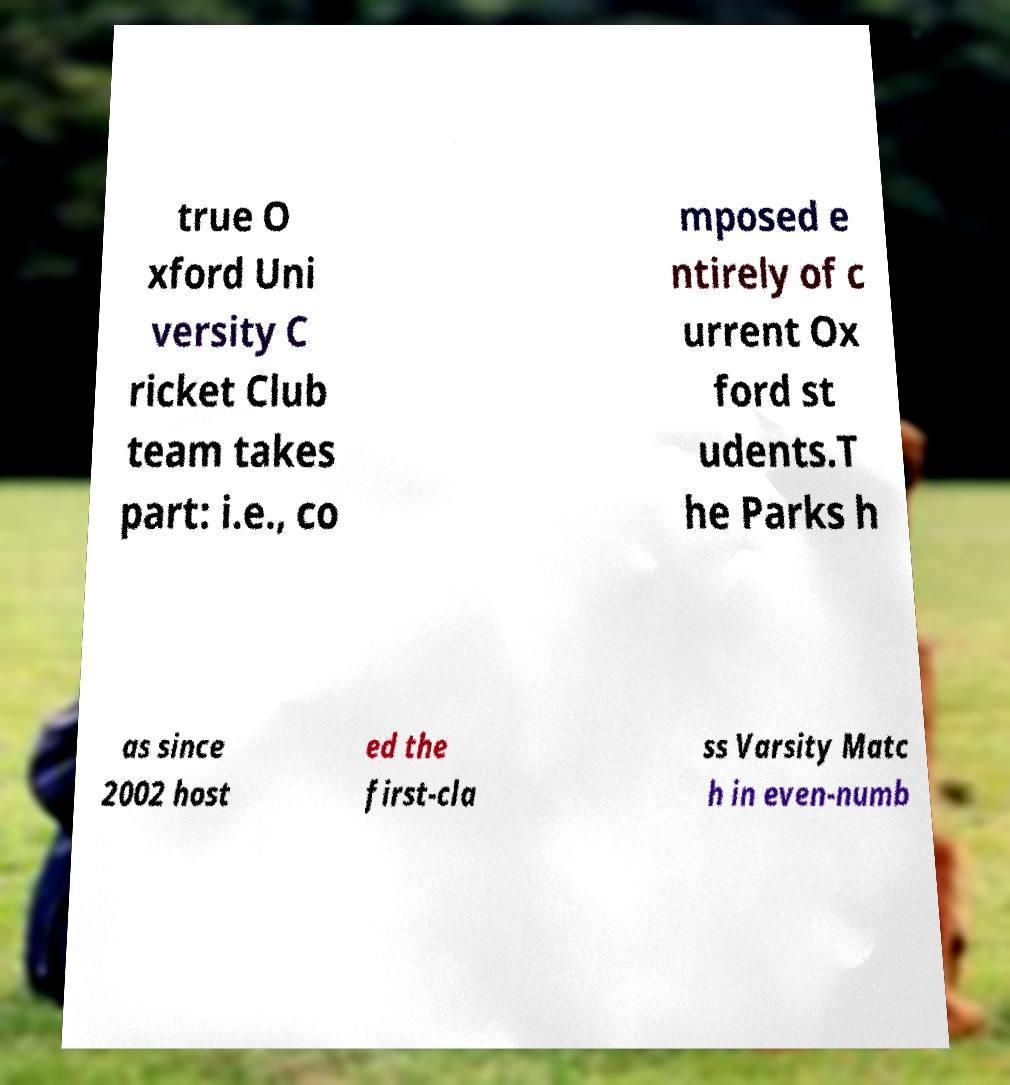I need the written content from this picture converted into text. Can you do that? true O xford Uni versity C ricket Club team takes part: i.e., co mposed e ntirely of c urrent Ox ford st udents.T he Parks h as since 2002 host ed the first-cla ss Varsity Matc h in even-numb 